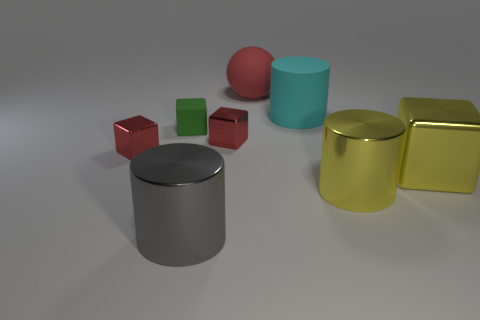What number of objects are either yellow blocks or red metallic cubes that are right of the green thing?
Offer a very short reply. 2. Is there a large yellow thing that is to the right of the yellow object that is to the left of the yellow cube?
Offer a very short reply. Yes. There is a large object that is to the left of the red thing that is to the right of the tiny object right of the small matte object; what shape is it?
Offer a very short reply. Cylinder. There is a shiny thing that is both on the left side of the large yellow metallic cube and to the right of the rubber sphere; what color is it?
Provide a short and direct response. Yellow. There is a large shiny object left of the large red sphere; what shape is it?
Your response must be concise. Cylinder. What shape is the red thing that is made of the same material as the small green thing?
Make the answer very short. Sphere. What number of matte objects are large red things or cyan things?
Your answer should be very brief. 2. How many big rubber cylinders are in front of the block to the right of the large shiny cylinder right of the big gray object?
Keep it short and to the point. 0. There is a red object that is behind the cyan cylinder; does it have the same size as the cylinder that is behind the green matte cube?
Provide a short and direct response. Yes. There is a large yellow thing that is the same shape as the big gray metallic thing; what material is it?
Keep it short and to the point. Metal. 